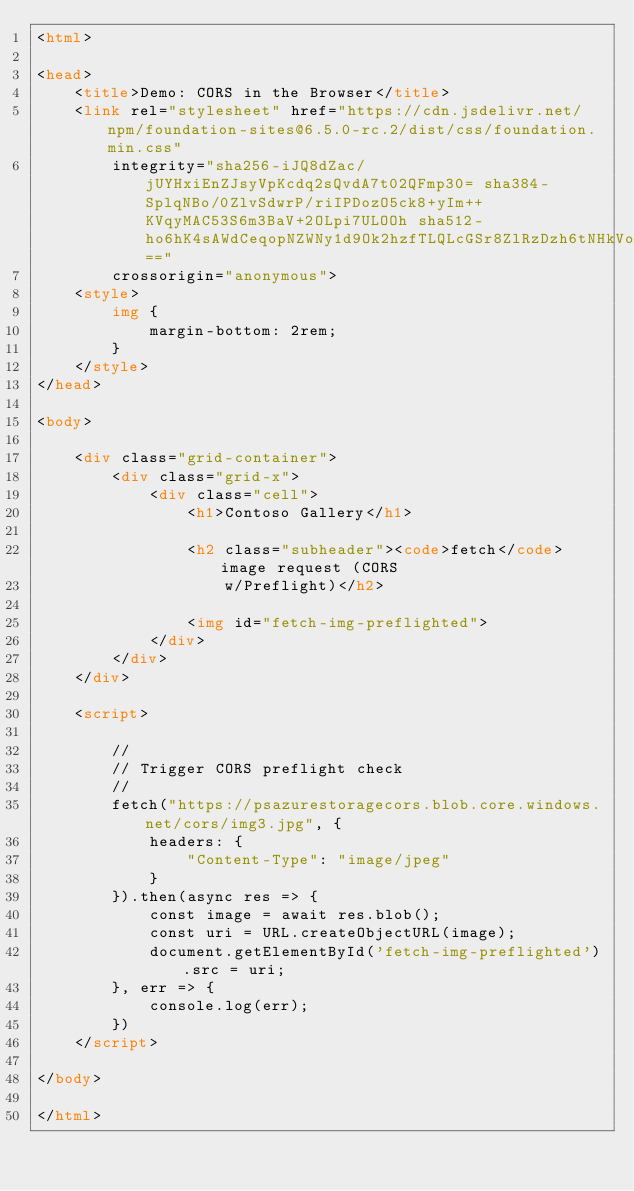Convert code to text. <code><loc_0><loc_0><loc_500><loc_500><_HTML_><html>

<head>
    <title>Demo: CORS in the Browser</title>
    <link rel="stylesheet" href="https://cdn.jsdelivr.net/npm/foundation-sites@6.5.0-rc.2/dist/css/foundation.min.css"
        integrity="sha256-iJQ8dZac/jUYHxiEnZJsyVpKcdq2sQvdA7t02QFmp30= sha384-SplqNBo/0ZlvSdwrP/riIPDozO5ck8+yIm++KVqyMAC53S6m3BaV+2OLpi7ULOOh sha512-ho6hK4sAWdCeqopNZWNy1d9Ok2hzfTLQLcGSr8ZlRzDzh6tNHkVoqSl6wgLsqls3yazwiG9H9dBCtSfPuiLRCQ=="
        crossorigin="anonymous">
    <style>
        img {
            margin-bottom: 2rem;
        }
    </style>
</head>

<body>

    <div class="grid-container">
        <div class="grid-x">
            <div class="cell">
                <h1>Contoso Gallery</h1>

                <h2 class="subheader"><code>fetch</code> image request (CORS
                    w/Preflight)</h2>

                <img id="fetch-img-preflighted">
            </div>
        </div>
    </div>

    <script>

        //
        // Trigger CORS preflight check
        //
        fetch("https://psazurestoragecors.blob.core.windows.net/cors/img3.jpg", {
            headers: {
                "Content-Type": "image/jpeg"
            }
        }).then(async res => {
            const image = await res.blob();
            const uri = URL.createObjectURL(image);
            document.getElementById('fetch-img-preflighted').src = uri;
        }, err => {
            console.log(err);
        })
    </script>

</body>

</html></code> 